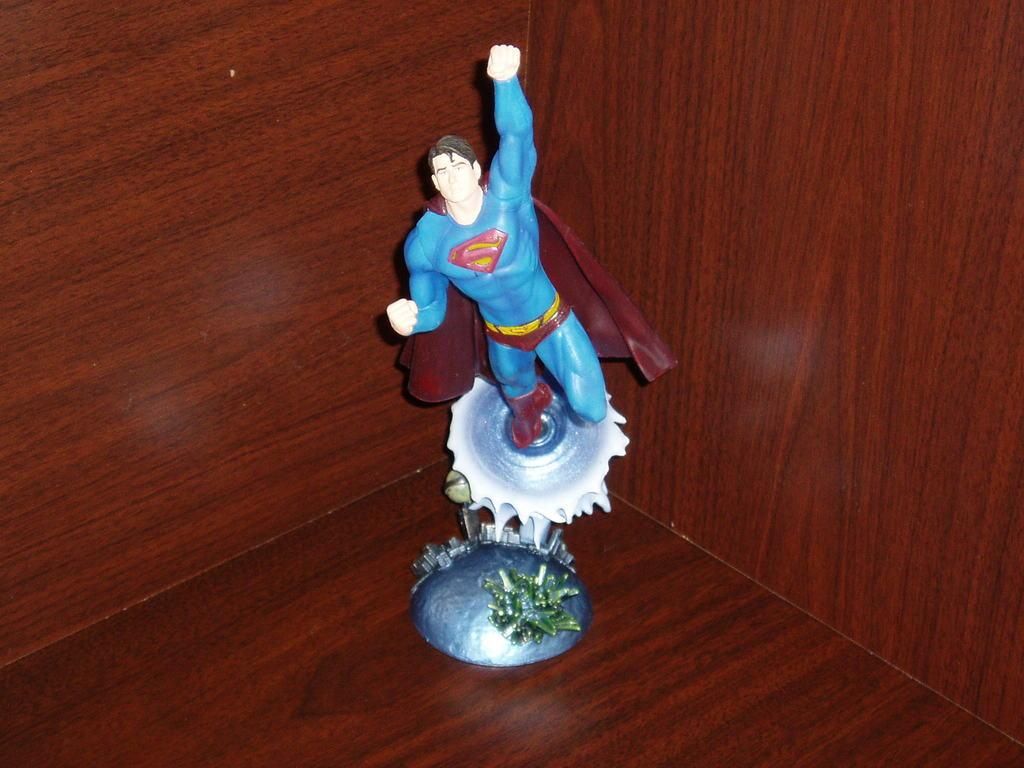What type of toy is present in the image? There is a toy of a superman in the image. What is the material of the container in the image? The container in the image is made of wood. What song is being sung by the superman toy in the image? There is no indication in the image that the superman toy is singing a song. 